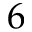<formula> <loc_0><loc_0><loc_500><loc_500>6</formula> 